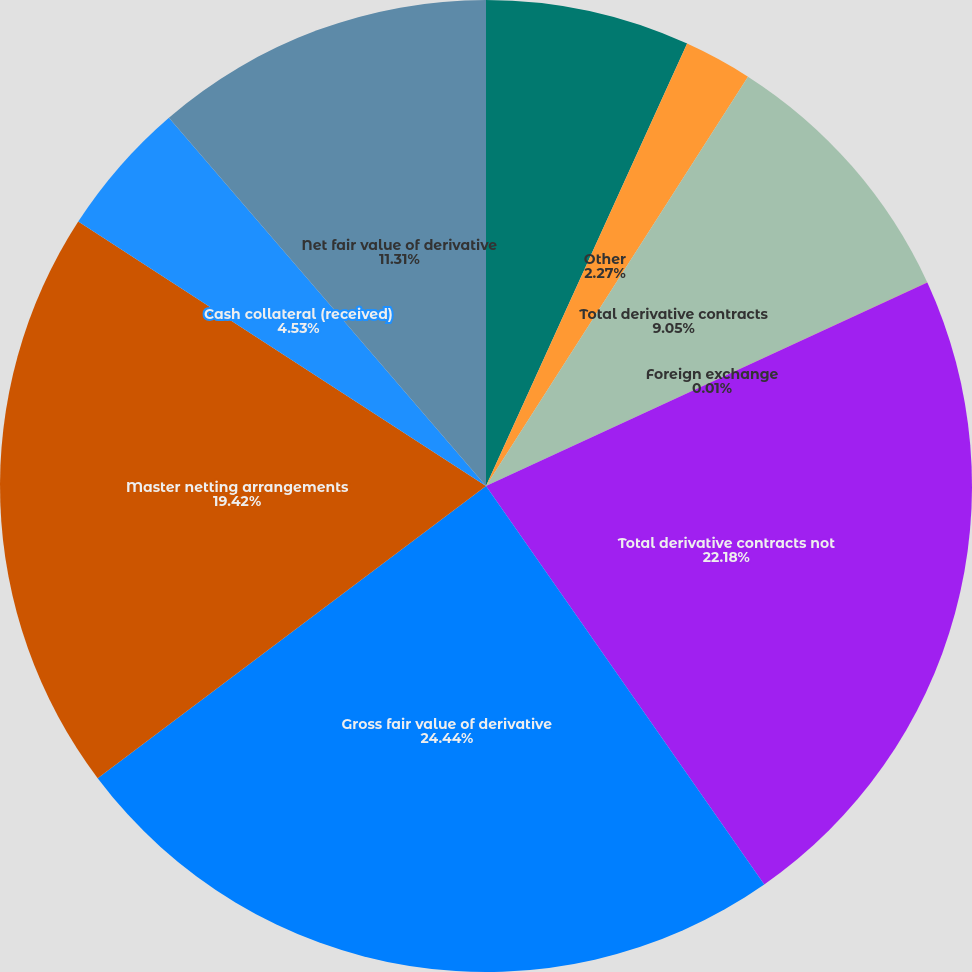Convert chart to OTSL. <chart><loc_0><loc_0><loc_500><loc_500><pie_chart><fcel>Commodity<fcel>Other<fcel>Total derivative contracts<fcel>Foreign exchange<fcel>Total derivative contracts not<fcel>Gross fair value of derivative<fcel>Master netting arrangements<fcel>Cash collateral (received)<fcel>Net fair value of derivative<nl><fcel>6.79%<fcel>2.27%<fcel>9.05%<fcel>0.01%<fcel>22.17%<fcel>24.43%<fcel>19.42%<fcel>4.53%<fcel>11.31%<nl></chart> 